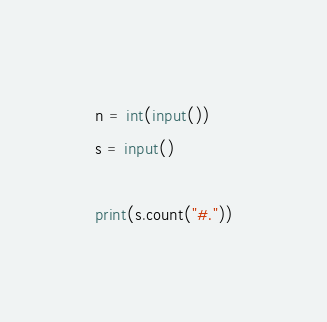Convert code to text. <code><loc_0><loc_0><loc_500><loc_500><_Python_>n = int(input())
s = input()

print(s.count("#."))
</code> 